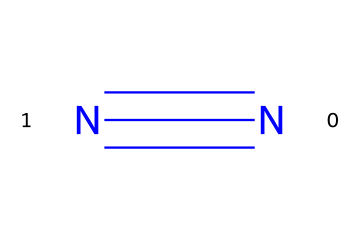What is the molecular formula of this compound? The compound is composed of two nitrogen atoms, which is represented by the SMILES notation, resulting in the molecular formula N2.
Answer: N2 How many bonds are present in the molecular structure? The SMILES notation shows a triple bond between the two nitrogen atoms (N#N), indicating that there are three bonds in total.
Answer: 3 What is the primary use of liquid nitrogen? Liquid nitrogen is primarily used in cryogenic experiments for cooling or preserving biological samples at extremely low temperatures.
Answer: cooling What type of intermolecular forces are present in liquid nitrogen? Liquid nitrogen experiences weak Van der Waals forces (London dispersion forces) due to its nonpolar nature, which arise from temporary dipoles.
Answer: Van der Waals Explain why liquid nitrogen is considered a cryogen. As a cryogen, liquid nitrogen is used to achieve very low temperatures of around -196 degrees Celsius, which is effective in preserving materials without causing ice crystal formation due to its low boiling point.
Answer: low temperatures What is the boiling point of liquid nitrogen? The boiling point of liquid nitrogen is approximately -196 degrees Celsius, which is crucial for its use in various cooling applications.
Answer: -196 degrees Celsius In what state is nitrogen at room temperature? At room temperature, nitrogen exists as a gas, but when cooled to liquid nitrogen temperatures, it condenses into a liquid state.
Answer: gas 